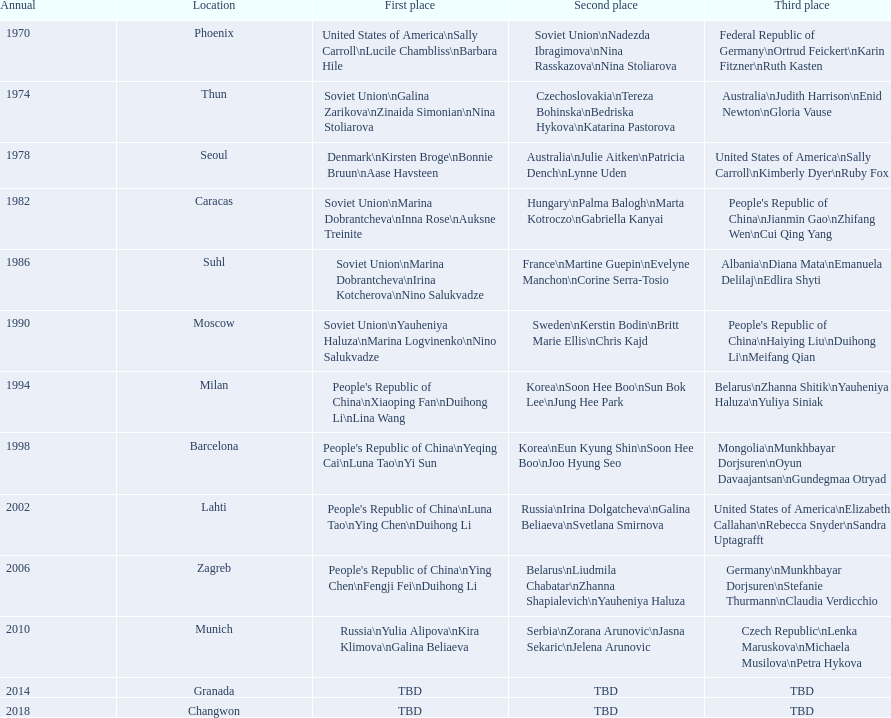What is the first place listed in this chart? Phoenix. 